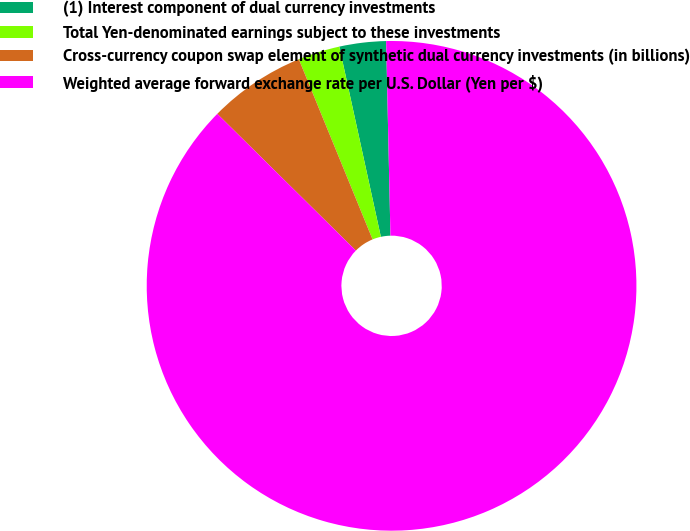Convert chart to OTSL. <chart><loc_0><loc_0><loc_500><loc_500><pie_chart><fcel>(1) Interest component of dual currency investments<fcel>Total Yen-denominated earnings subject to these investments<fcel>Cross-currency coupon swap element of synthetic dual currency investments (in billions)<fcel>Weighted average forward exchange rate per U.S. Dollar (Yen per $)<nl><fcel>3.07%<fcel>2.76%<fcel>6.42%<fcel>87.74%<nl></chart> 